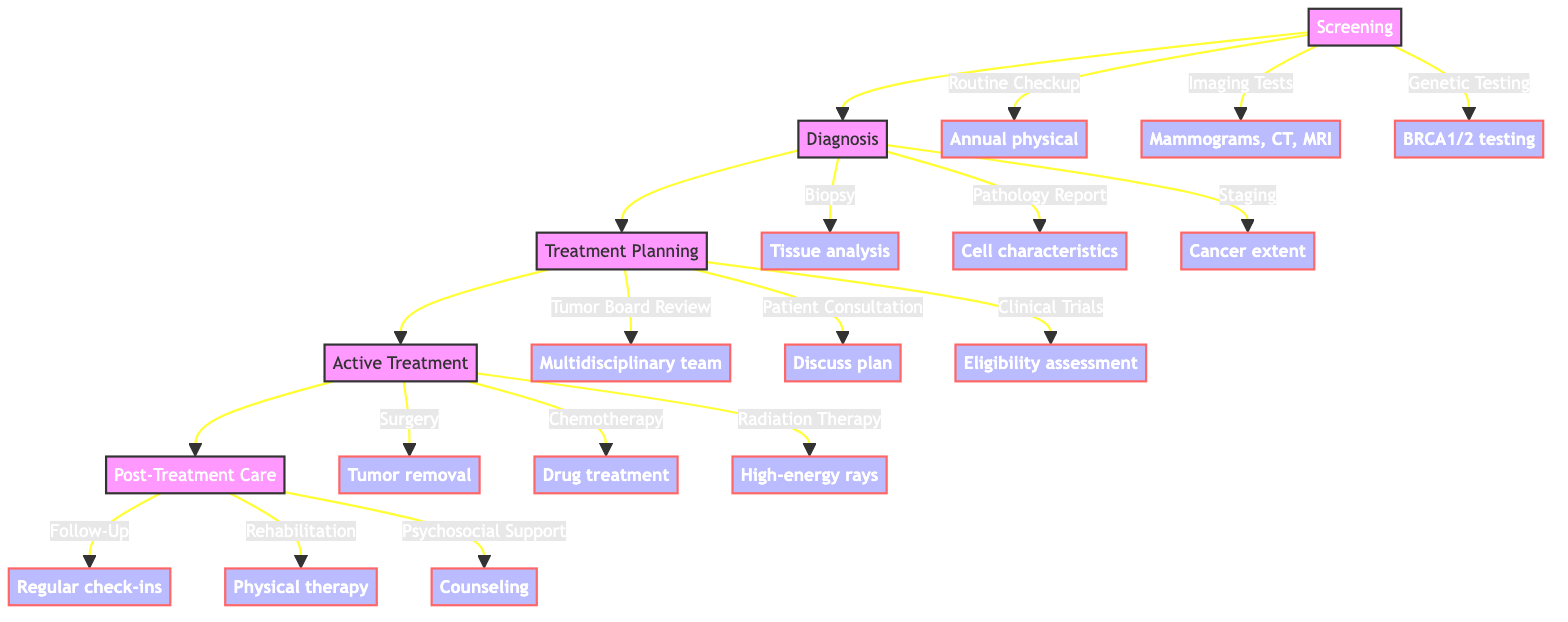What are the stages of the patient journey? The diagram displays five stages: Screening, Diagnosis, Treatment Planning, Active Treatment, and Post-Treatment Care. These are sequentially connected, indicating the progression of the patient journey.
Answer: Screening, Diagnosis, Treatment Planning, Active Treatment, Post-Treatment Care How many elements are in the Active Treatment stage? In the Active Treatment stage, there are three elements: Surgery, Chemotherapy, and Radiation Therapy. These are explicitly listed under the Active Treatment node.
Answer: 3 What type of tests are included in the Screening stage? The Screening stage includes three tests: Routine Checkup, Imaging Tests, and Genetic Testing. These tests aim at early detection of cancer.
Answer: Routine Checkup, Imaging Tests, Genetic Testing What follows the Diagnosis stage in the patient journey? After the Diagnosis stage, the next stage is Treatment Planning. This flow is clearly illustrated in the diagram as a direct connection from Diagnosis to Treatment Planning.
Answer: Treatment Planning Which element involves a multidisciplinary team? The element that involves a multidisciplinary team is "Tumor Board Review," which is part of the Treatment Planning stage. This highlights the collaborative approach in deciding treatment options.
Answer: Tumor Board Review What is the purpose of psychosocial support in Post-Treatment Care? The purpose of Psychosocial Support is to provide counseling and support groups to ensure emotional well-being after treatment. It reflects the importance of mental health during recovery.
Answer: Counseling and support groups Which stage includes the element "Follow-Up Appointments"? The element "Follow-Up Appointments" is found in the Post-Treatment Care stage. This indicates the ongoing monitoring of health after active treatment has concluded.
Answer: Post-Treatment Care How many elements are associated with the Screening stage? The Screening stage consists of three elements: Routine Checkup, Imaging Tests, and Genetic Testing. Counting each listed element reaches this total.
Answer: 3 What is the last element in the entire patient journey? The last element in the patient journey is "Psychosocial Support," which is part of the Post-Treatment Care stage, indicating focus on emotional and psychological recovery.
Answer: Psychosocial Support 